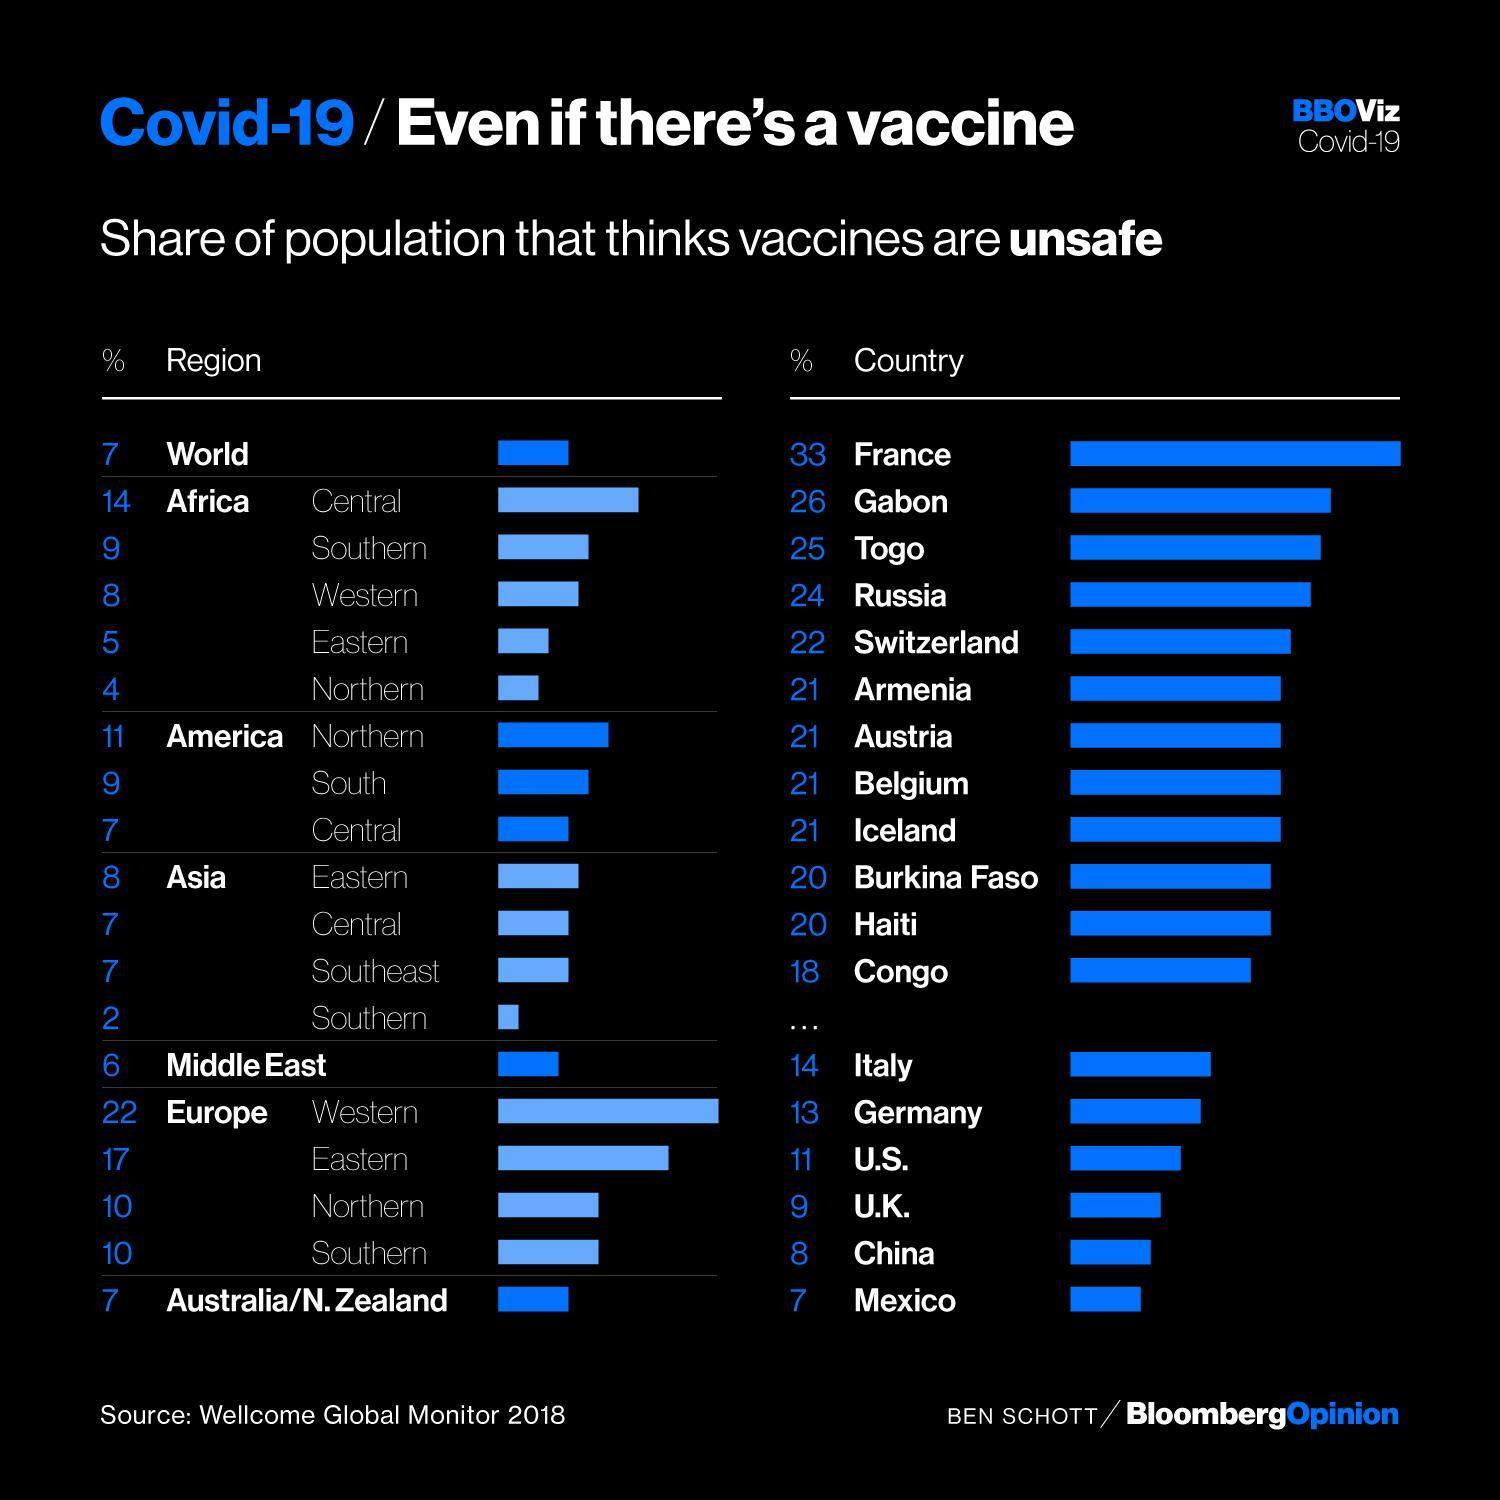Other than Haiti, which other country do a population of 20% think that vaccines are unsafe
Answer the question with a short phrase. Burkina Faso The population of which part of Asia trust vaccines more Southern What % of total population of Central and Southern Africa think that vaccines are unsafe 23 Which country do the maximum population think that vaccines are unsafe France The population of which country trust in vaccines more than the Chinese Mexico 